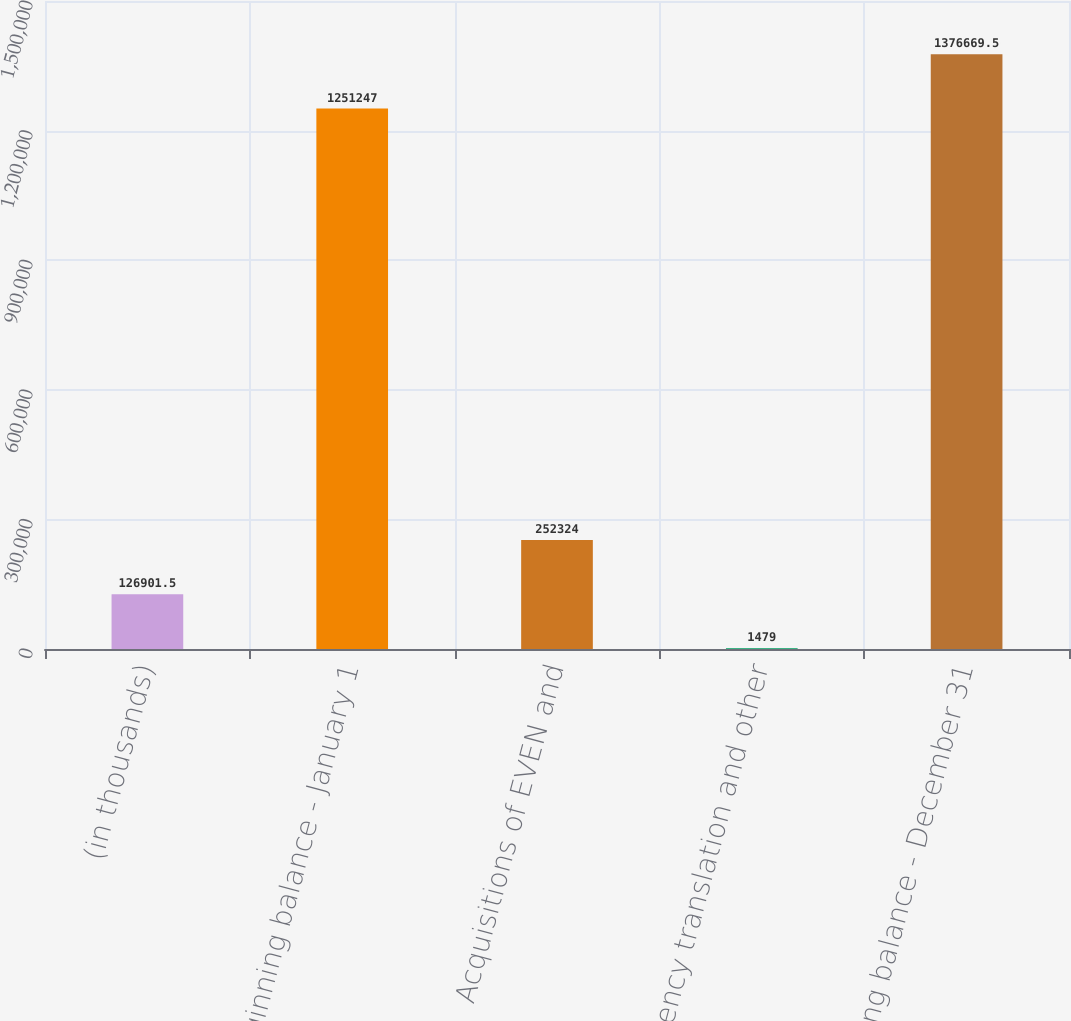Convert chart. <chart><loc_0><loc_0><loc_500><loc_500><bar_chart><fcel>(in thousands)<fcel>Beginning balance - January 1<fcel>Acquisitions of EVEN and<fcel>Currency translation and other<fcel>Ending balance - December 31<nl><fcel>126902<fcel>1.25125e+06<fcel>252324<fcel>1479<fcel>1.37667e+06<nl></chart> 